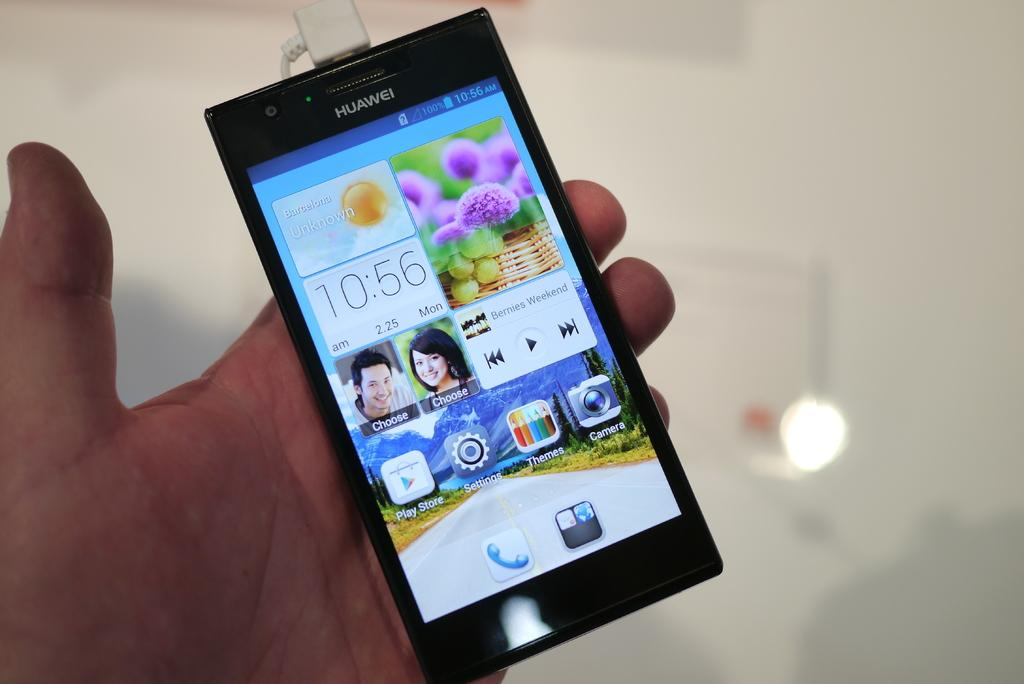<image>
Give a short and clear explanation of the subsequent image. A Huawei smart phone electronic device being held in a hand. 